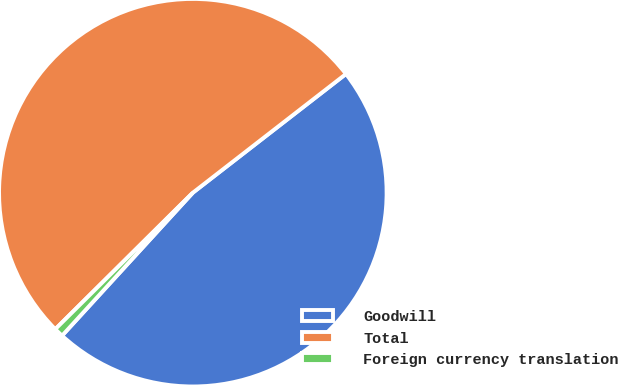Convert chart to OTSL. <chart><loc_0><loc_0><loc_500><loc_500><pie_chart><fcel>Goodwill<fcel>Total<fcel>Foreign currency translation<nl><fcel>47.29%<fcel>51.94%<fcel>0.77%<nl></chart> 